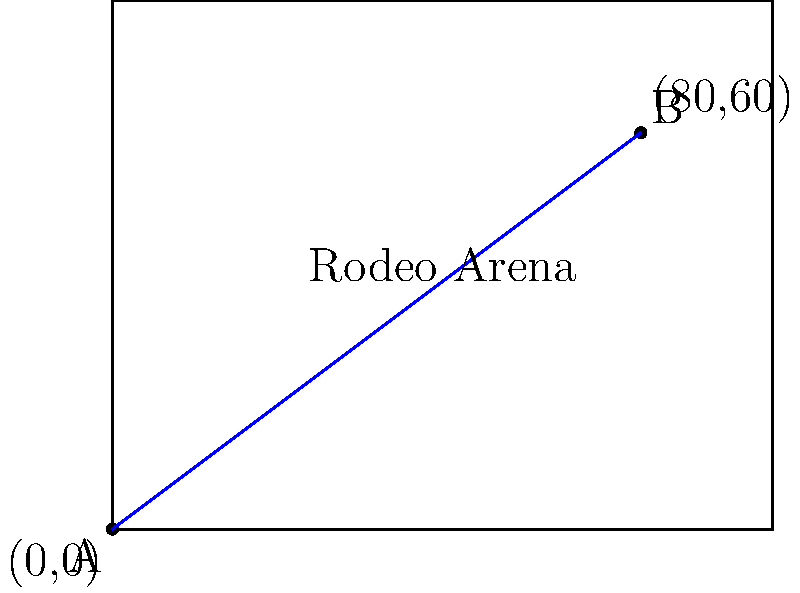At the local rodeo arena, you need to determine the slope of a line connecting two points for a new event layout. Point A is at the southwest corner (0,0), and Point B is at (80,60) feet. What is the slope of the line connecting these two points? To find the slope of a line connecting two points, we use the slope formula:

$$ \text{Slope} = \frac{y_2 - y_1}{x_2 - x_1} $$

Where $(x_1, y_1)$ is the first point and $(x_2, y_2)$ is the second point.

Given:
- Point A: $(0, 0)$
- Point B: $(80, 60)$

Let's plug these values into the formula:

$$ \text{Slope} = \frac{60 - 0}{80 - 0} = \frac{60}{80} $$

Simplify the fraction:

$$ \frac{60}{80} = \frac{3}{4} = 0.75 $$

Therefore, the slope of the line connecting points A and B is $\frac{3}{4}$ or 0.75.
Answer: $\frac{3}{4}$ or 0.75 